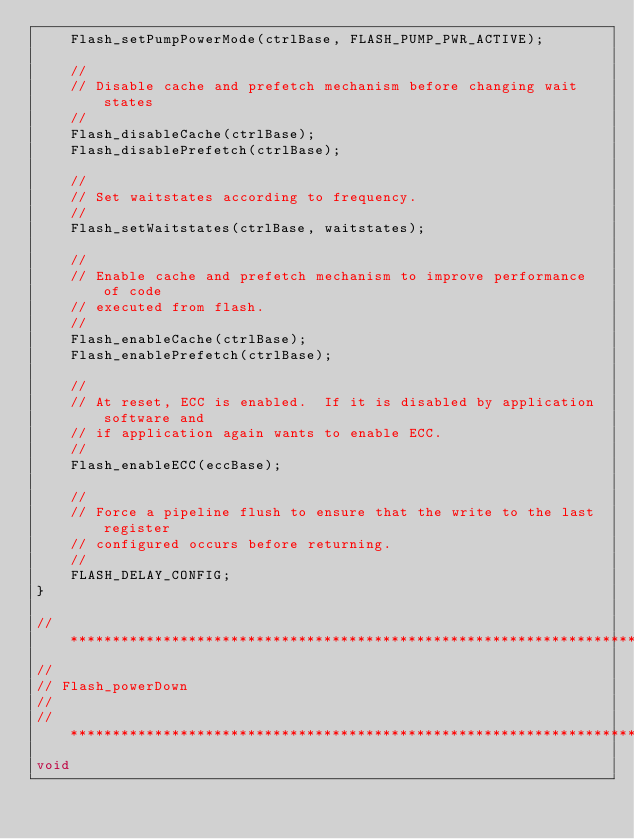<code> <loc_0><loc_0><loc_500><loc_500><_C_>    Flash_setPumpPowerMode(ctrlBase, FLASH_PUMP_PWR_ACTIVE);

    //
    // Disable cache and prefetch mechanism before changing wait states
    //
    Flash_disableCache(ctrlBase);
    Flash_disablePrefetch(ctrlBase);

    //
    // Set waitstates according to frequency.
    //
    Flash_setWaitstates(ctrlBase, waitstates);

    //
    // Enable cache and prefetch mechanism to improve performance of code
    // executed from flash.
    //
    Flash_enableCache(ctrlBase);
    Flash_enablePrefetch(ctrlBase);

    //
    // At reset, ECC is enabled.  If it is disabled by application software and
    // if application again wants to enable ECC.
    //
    Flash_enableECC(eccBase);

    //
    // Force a pipeline flush to ensure that the write to the last register
    // configured occurs before returning.
    //
    FLASH_DELAY_CONFIG;
}

//*****************************************************************************
//
// Flash_powerDown
//
//*****************************************************************************
void</code> 